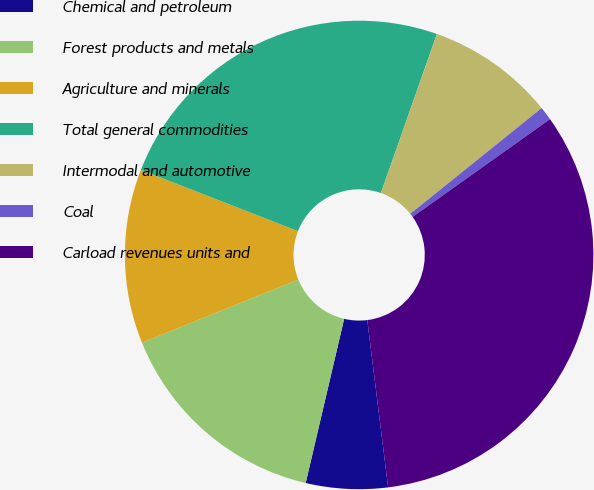Convert chart to OTSL. <chart><loc_0><loc_0><loc_500><loc_500><pie_chart><fcel>Chemical and petroleum<fcel>Forest products and metals<fcel>Agriculture and minerals<fcel>Total general commodities<fcel>Intermodal and automotive<fcel>Coal<fcel>Carload revenues units and<nl><fcel>5.64%<fcel>15.22%<fcel>12.03%<fcel>24.47%<fcel>8.83%<fcel>0.94%<fcel>32.87%<nl></chart> 